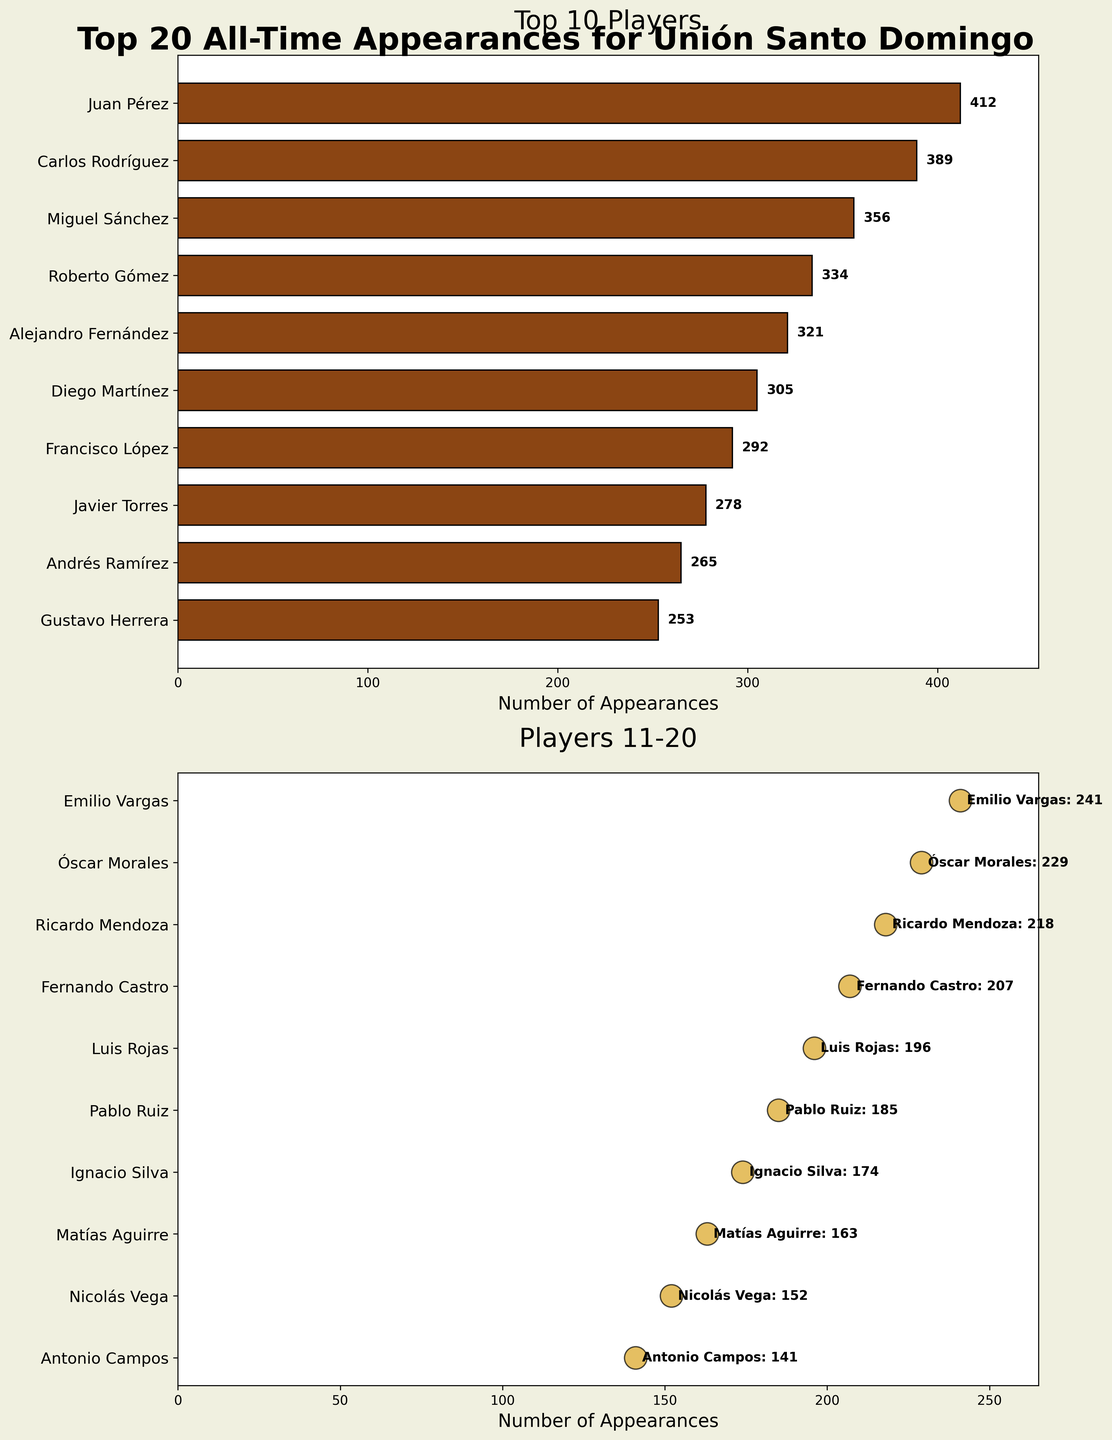Which player has the most appearances among the top 10 players? Looking at the bar plot for the top 10 players, Juan Pérez has the highest bar indicating he has the most appearances.
Answer: Juan Pérez Who are the players with the top 5 number of appearances? Analyzing the bar plot for the top 10 players, the five players with the highest bars are: Juan Pérez, Carlos Rodríguez, Miguel Sánchez, Roberto Gómez, and Alejandro Fernández.
Answer: Juan Pérez, Carlos Rodríguez, Miguel Sánchez, Roberto Gómez, Alejandro Fernández How many total appearances do the top 3 players have? The individual appearances for the top 3 players are Juan Pérez (412), Carlos Rodríguez (389), and Miguel Sánchez (356). Their total appearances are 412 + 389 + 356 = 1157.
Answer: 1157 What is the difference in appearances between Diego Martínez and Francisco López? From the bar plot, Diego Martínez has 305 appearances, and Francisco López has 292. The difference is 305 - 292 = 13.
Answer: 13 Who has more appearances, Gustavo Herrera or Ricardo Mendoza? By comparing the scatter plot for players 11-20, Gustavo Herrera (253 appearances) has more than Ricardo Mendoza (218 appearances).
Answer: Gustavo Herrera How many appearances does the player with the 15th most appearances have? Referring to the scatter plot for players 11-20, the 15th player listed is Pablo Ruiz, who has 185 appearances.
Answer: 185 What is the average number of appearances for players ranked 15 to 20? The respective appearances for players 15 to 20 are 196, 185, 174, 163, 152, and 141. Summing them gives 196 + 185 + 174 + 163 + 152 + 141 = 1011. The average is 1011 / 6 = 168.5.
Answer: 168.5 Who are the players with fewer than 250 appearances among the top 20? Analyzing both plots, within the top 20 players, those with fewer than 250 appearances are Emilio Vargas, Óscar Morales, Ricardo Mendoza, Fernando Castro, Luis Rojas, Pablo Ruiz, Ignacio Silva, Matías Aguirre, Nicolás Vega, and Antonio Campos.
Answer: Emilio Vargas, Óscar Morales, Ricardo Mendoza, Fernando Castro, Luis Rojas, Pablo Ruiz, Ignacio Silva, Matías Aguirre, Nicolás Vega, Antonio Campos 